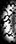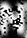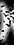Read the text from these images in sequence, separated by a semicolon. (; N; ) 